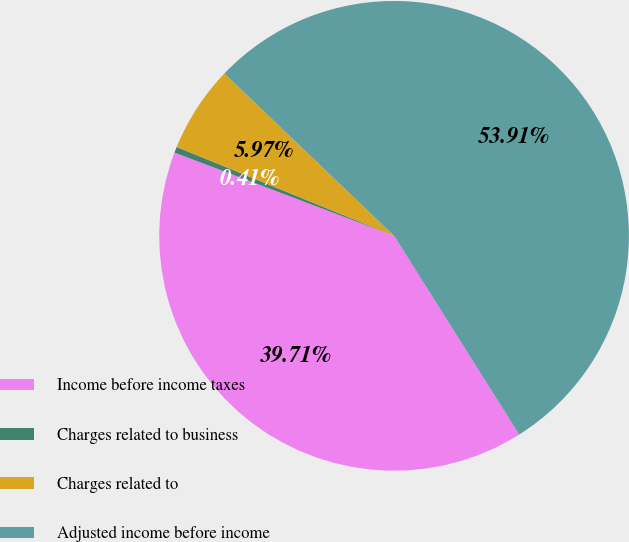Convert chart. <chart><loc_0><loc_0><loc_500><loc_500><pie_chart><fcel>Income before income taxes<fcel>Charges related to business<fcel>Charges related to<fcel>Adjusted income before income<nl><fcel>39.71%<fcel>0.41%<fcel>5.97%<fcel>53.91%<nl></chart> 